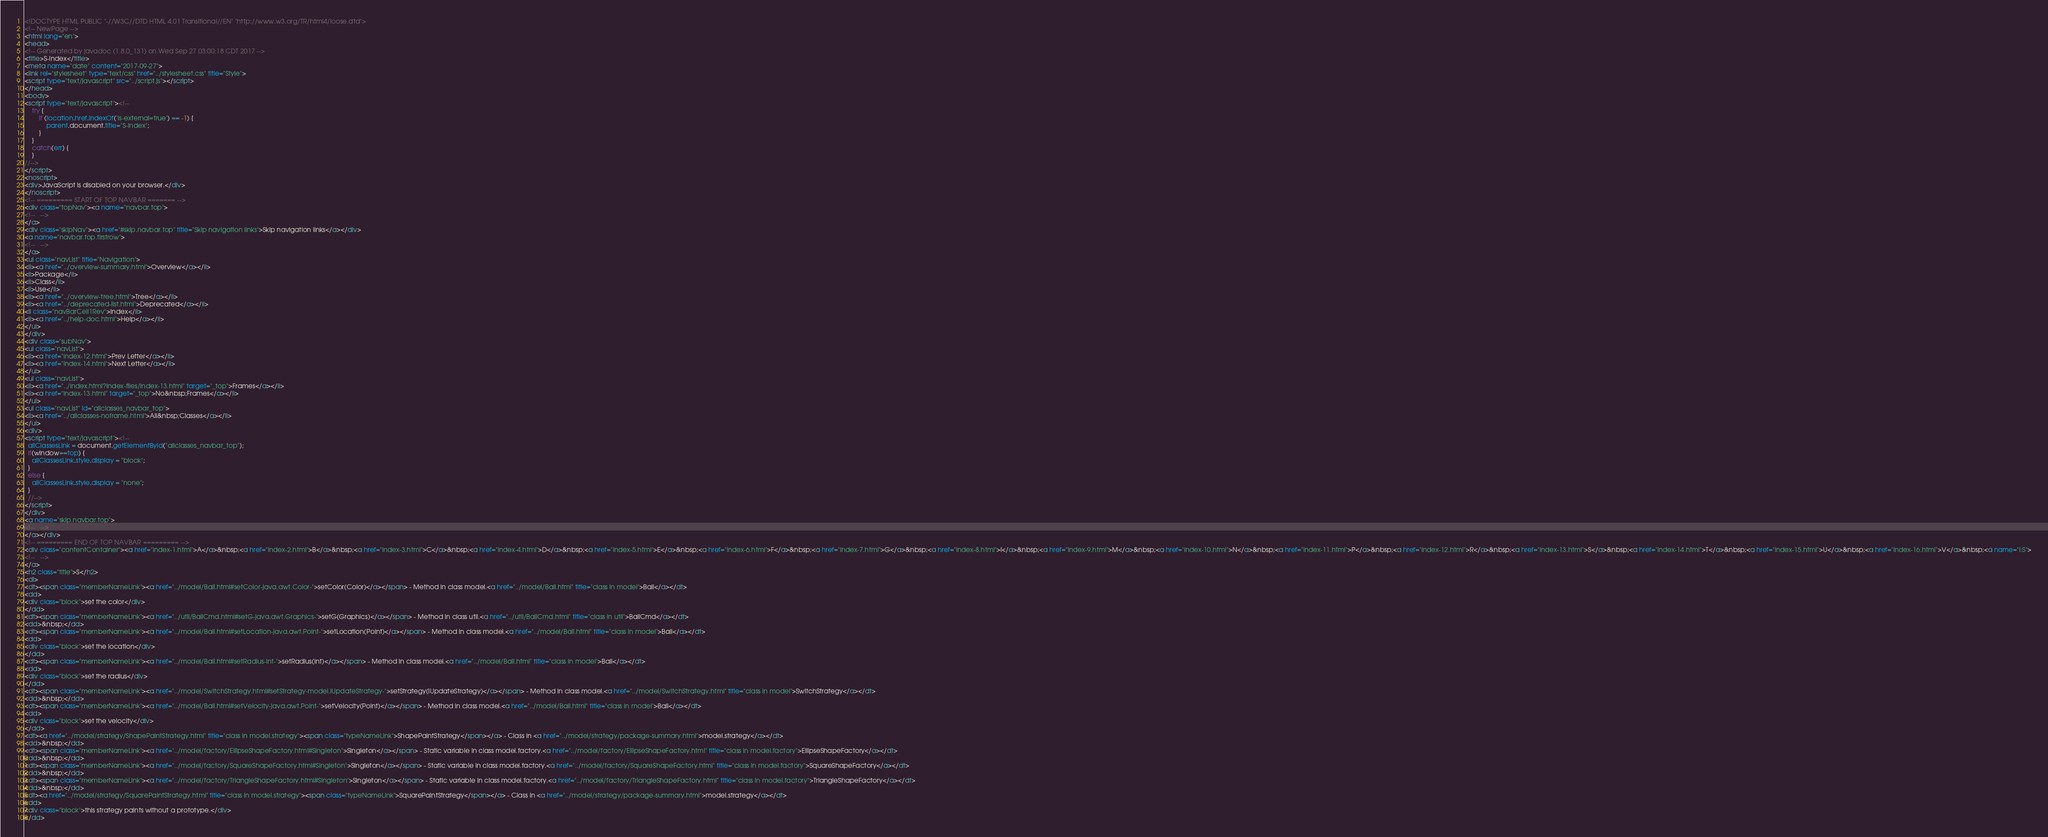<code> <loc_0><loc_0><loc_500><loc_500><_HTML_><!DOCTYPE HTML PUBLIC "-//W3C//DTD HTML 4.01 Transitional//EN" "http://www.w3.org/TR/html4/loose.dtd">
<!-- NewPage -->
<html lang="en">
<head>
<!-- Generated by javadoc (1.8.0_131) on Wed Sep 27 03:00:18 CDT 2017 -->
<title>S-Index</title>
<meta name="date" content="2017-09-27">
<link rel="stylesheet" type="text/css" href="../stylesheet.css" title="Style">
<script type="text/javascript" src="../script.js"></script>
</head>
<body>
<script type="text/javascript"><!--
    try {
        if (location.href.indexOf('is-external=true') == -1) {
            parent.document.title="S-Index";
        }
    }
    catch(err) {
    }
//-->
</script>
<noscript>
<div>JavaScript is disabled on your browser.</div>
</noscript>
<!-- ========= START OF TOP NAVBAR ======= -->
<div class="topNav"><a name="navbar.top">
<!--   -->
</a>
<div class="skipNav"><a href="#skip.navbar.top" title="Skip navigation links">Skip navigation links</a></div>
<a name="navbar.top.firstrow">
<!--   -->
</a>
<ul class="navList" title="Navigation">
<li><a href="../overview-summary.html">Overview</a></li>
<li>Package</li>
<li>Class</li>
<li>Use</li>
<li><a href="../overview-tree.html">Tree</a></li>
<li><a href="../deprecated-list.html">Deprecated</a></li>
<li class="navBarCell1Rev">Index</li>
<li><a href="../help-doc.html">Help</a></li>
</ul>
</div>
<div class="subNav">
<ul class="navList">
<li><a href="index-12.html">Prev Letter</a></li>
<li><a href="index-14.html">Next Letter</a></li>
</ul>
<ul class="navList">
<li><a href="../index.html?index-files/index-13.html" target="_top">Frames</a></li>
<li><a href="index-13.html" target="_top">No&nbsp;Frames</a></li>
</ul>
<ul class="navList" id="allclasses_navbar_top">
<li><a href="../allclasses-noframe.html">All&nbsp;Classes</a></li>
</ul>
<div>
<script type="text/javascript"><!--
  allClassesLink = document.getElementById("allclasses_navbar_top");
  if(window==top) {
    allClassesLink.style.display = "block";
  }
  else {
    allClassesLink.style.display = "none";
  }
  //-->
</script>
</div>
<a name="skip.navbar.top">
<!--   -->
</a></div>
<!-- ========= END OF TOP NAVBAR ========= -->
<div class="contentContainer"><a href="index-1.html">A</a>&nbsp;<a href="index-2.html">B</a>&nbsp;<a href="index-3.html">C</a>&nbsp;<a href="index-4.html">D</a>&nbsp;<a href="index-5.html">E</a>&nbsp;<a href="index-6.html">F</a>&nbsp;<a href="index-7.html">G</a>&nbsp;<a href="index-8.html">I</a>&nbsp;<a href="index-9.html">M</a>&nbsp;<a href="index-10.html">N</a>&nbsp;<a href="index-11.html">P</a>&nbsp;<a href="index-12.html">R</a>&nbsp;<a href="index-13.html">S</a>&nbsp;<a href="index-14.html">T</a>&nbsp;<a href="index-15.html">U</a>&nbsp;<a href="index-16.html">V</a>&nbsp;<a name="I:S">
<!--   -->
</a>
<h2 class="title">S</h2>
<dl>
<dt><span class="memberNameLink"><a href="../model/Ball.html#setColor-java.awt.Color-">setColor(Color)</a></span> - Method in class model.<a href="../model/Ball.html" title="class in model">Ball</a></dt>
<dd>
<div class="block">set the color</div>
</dd>
<dt><span class="memberNameLink"><a href="../util/BallCmd.html#setG-java.awt.Graphics-">setG(Graphics)</a></span> - Method in class util.<a href="../util/BallCmd.html" title="class in util">BallCmd</a></dt>
<dd>&nbsp;</dd>
<dt><span class="memberNameLink"><a href="../model/Ball.html#setLocation-java.awt.Point-">setLocation(Point)</a></span> - Method in class model.<a href="../model/Ball.html" title="class in model">Ball</a></dt>
<dd>
<div class="block">set the location</div>
</dd>
<dt><span class="memberNameLink"><a href="../model/Ball.html#setRadius-int-">setRadius(int)</a></span> - Method in class model.<a href="../model/Ball.html" title="class in model">Ball</a></dt>
<dd>
<div class="block">set the radius</div>
</dd>
<dt><span class="memberNameLink"><a href="../model/SwitchStrategy.html#setStrategy-model.IUpdateStrategy-">setStrategy(IUpdateStrategy)</a></span> - Method in class model.<a href="../model/SwitchStrategy.html" title="class in model">SwitchStrategy</a></dt>
<dd>&nbsp;</dd>
<dt><span class="memberNameLink"><a href="../model/Ball.html#setVelocity-java.awt.Point-">setVelocity(Point)</a></span> - Method in class model.<a href="../model/Ball.html" title="class in model">Ball</a></dt>
<dd>
<div class="block">set the velocity</div>
</dd>
<dt><a href="../model/strategy/ShapePaintStrategy.html" title="class in model.strategy"><span class="typeNameLink">ShapePaintStrategy</span></a> - Class in <a href="../model/strategy/package-summary.html">model.strategy</a></dt>
<dd>&nbsp;</dd>
<dt><span class="memberNameLink"><a href="../model/factory/EllipseShapeFactory.html#Singleton">Singleton</a></span> - Static variable in class model.factory.<a href="../model/factory/EllipseShapeFactory.html" title="class in model.factory">EllipseShapeFactory</a></dt>
<dd>&nbsp;</dd>
<dt><span class="memberNameLink"><a href="../model/factory/SquareShapeFactory.html#Singleton">Singleton</a></span> - Static variable in class model.factory.<a href="../model/factory/SquareShapeFactory.html" title="class in model.factory">SquareShapeFactory</a></dt>
<dd>&nbsp;</dd>
<dt><span class="memberNameLink"><a href="../model/factory/TriangleShapeFactory.html#Singleton">Singleton</a></span> - Static variable in class model.factory.<a href="../model/factory/TriangleShapeFactory.html" title="class in model.factory">TriangleShapeFactory</a></dt>
<dd>&nbsp;</dd>
<dt><a href="../model/strategy/SquarePaintStrategy.html" title="class in model.strategy"><span class="typeNameLink">SquarePaintStrategy</span></a> - Class in <a href="../model/strategy/package-summary.html">model.strategy</a></dt>
<dd>
<div class="block">this strategy paints without a prototype.</div>
</dd></code> 